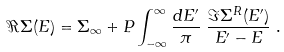<formula> <loc_0><loc_0><loc_500><loc_500>\Re \Sigma ( E ) & = \Sigma _ { \infty } + P \int _ { - \infty } ^ { \infty } \frac { d E ^ { \prime } } { \pi } \ \frac { \Im \Sigma ^ { R } ( E ^ { \prime } ) } { E ^ { \prime } - E } \ .</formula> 